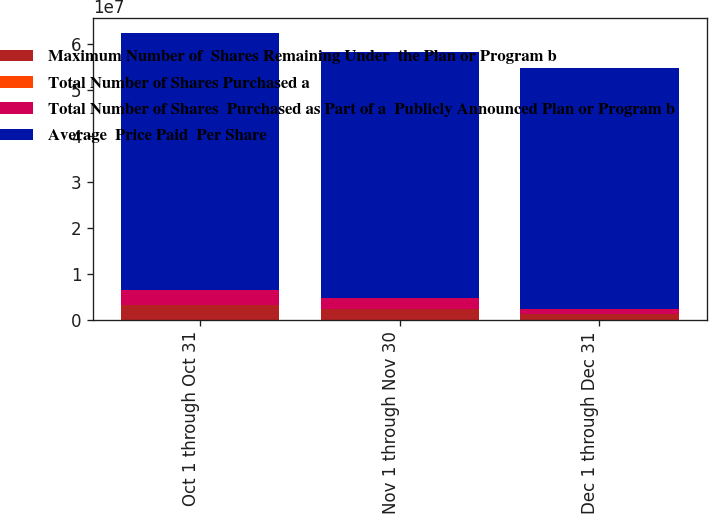Convert chart. <chart><loc_0><loc_0><loc_500><loc_500><stacked_bar_chart><ecel><fcel>Oct 1 through Oct 31<fcel>Nov 1 through Nov 30<fcel>Dec 1 through Dec 31<nl><fcel>Maximum Number of  Shares Remaining Under  the Plan or Program b<fcel>3.24773e+06<fcel>2.32586e+06<fcel>1.10539e+06<nl><fcel>Total Number of Shares Purchased a<fcel>92.98<fcel>86.61<fcel>77.63<nl><fcel>Total Number of Shares  Purchased as Part of a  Publicly Announced Plan or Program b<fcel>3.22115e+06<fcel>2.32299e+06<fcel>1.10275e+06<nl><fcel>Average  Price Paid  Per Share<fcel>5.60782e+07<fcel>5.37552e+07<fcel>5.26524e+07<nl></chart> 